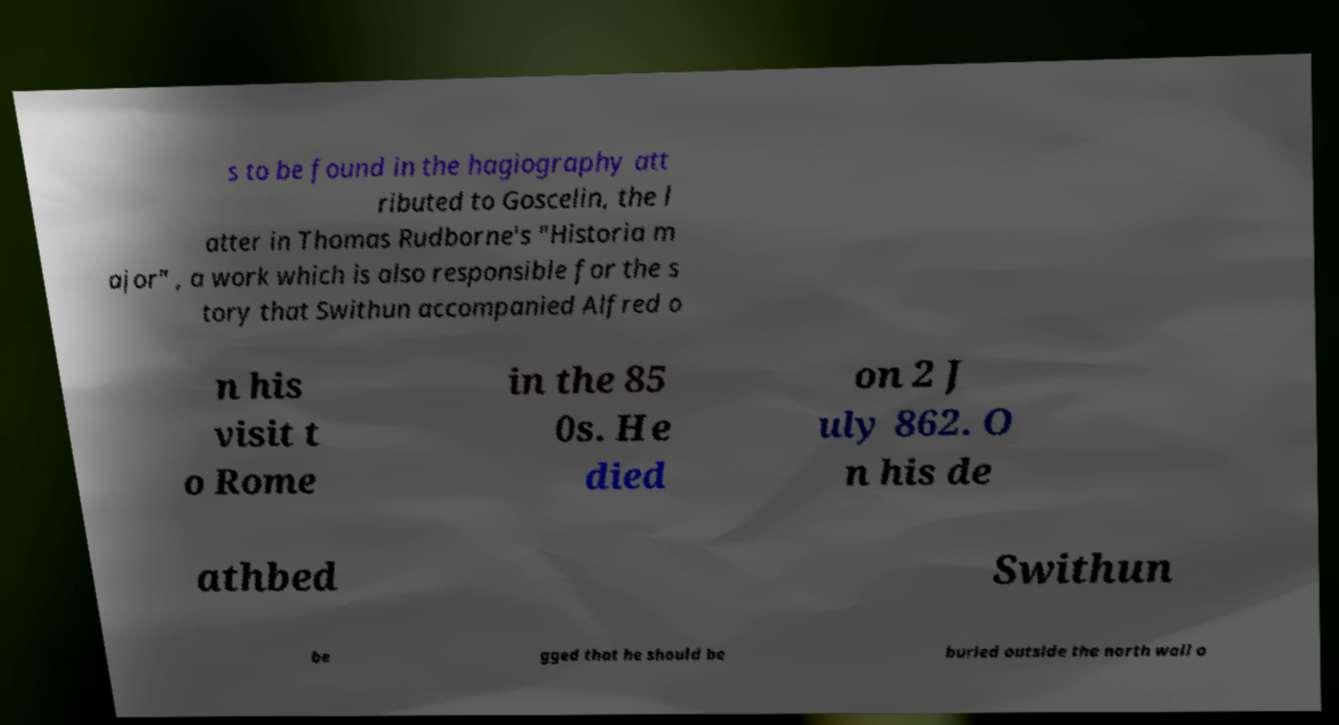Can you accurately transcribe the text from the provided image for me? s to be found in the hagiography att ributed to Goscelin, the l atter in Thomas Rudborne's "Historia m ajor" , a work which is also responsible for the s tory that Swithun accompanied Alfred o n his visit t o Rome in the 85 0s. He died on 2 J uly 862. O n his de athbed Swithun be gged that he should be buried outside the north wall o 